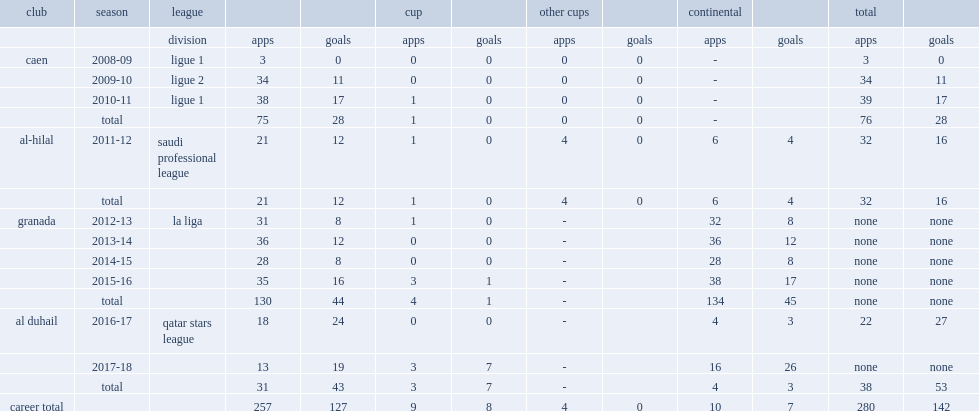How many goals did youssef el-arabi score for granada totally? 45.0. 